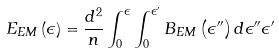Convert formula to latex. <formula><loc_0><loc_0><loc_500><loc_500>E _ { E M } \left ( \epsilon \right ) = \frac { d ^ { 2 } } { n } \int _ { 0 } ^ { \epsilon } \int _ { 0 } ^ { \epsilon ^ { \prime } } B _ { E M } \left ( \epsilon ^ { \prime \prime } \right ) d \epsilon ^ { \prime \prime } \epsilon ^ { \prime }</formula> 